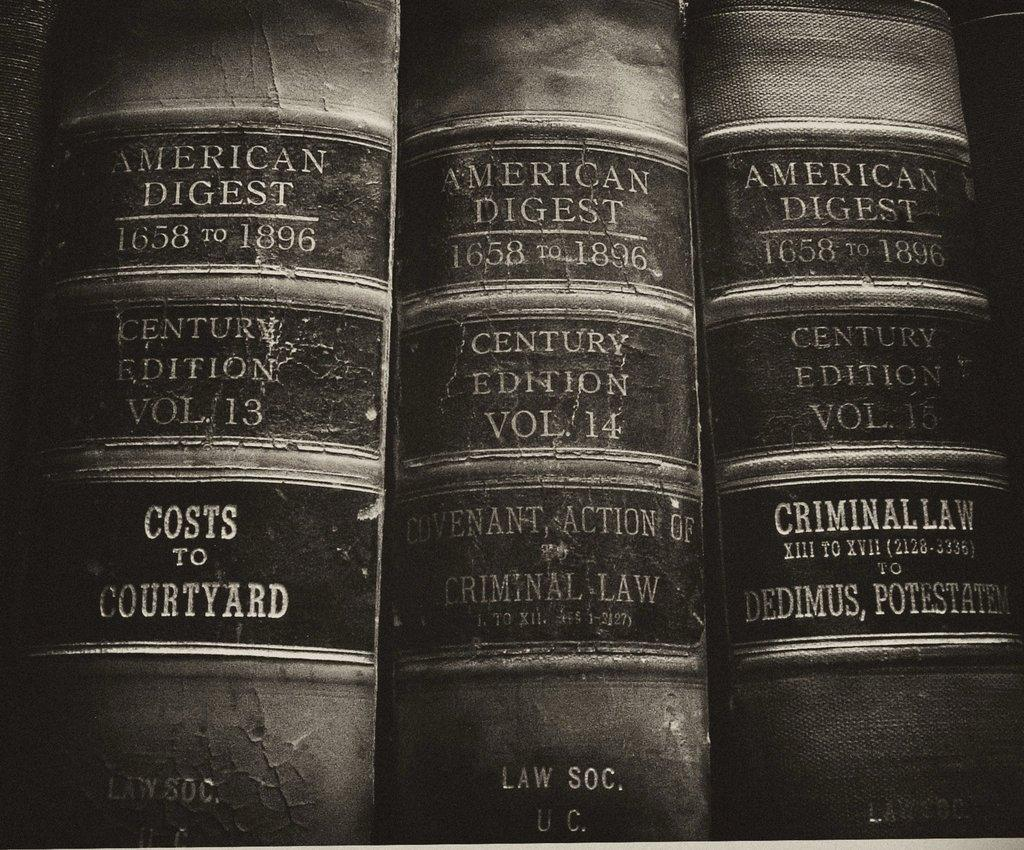<image>
Render a clear and concise summary of the photo. The spines of three American Digest law books from 1658 to 1896. 